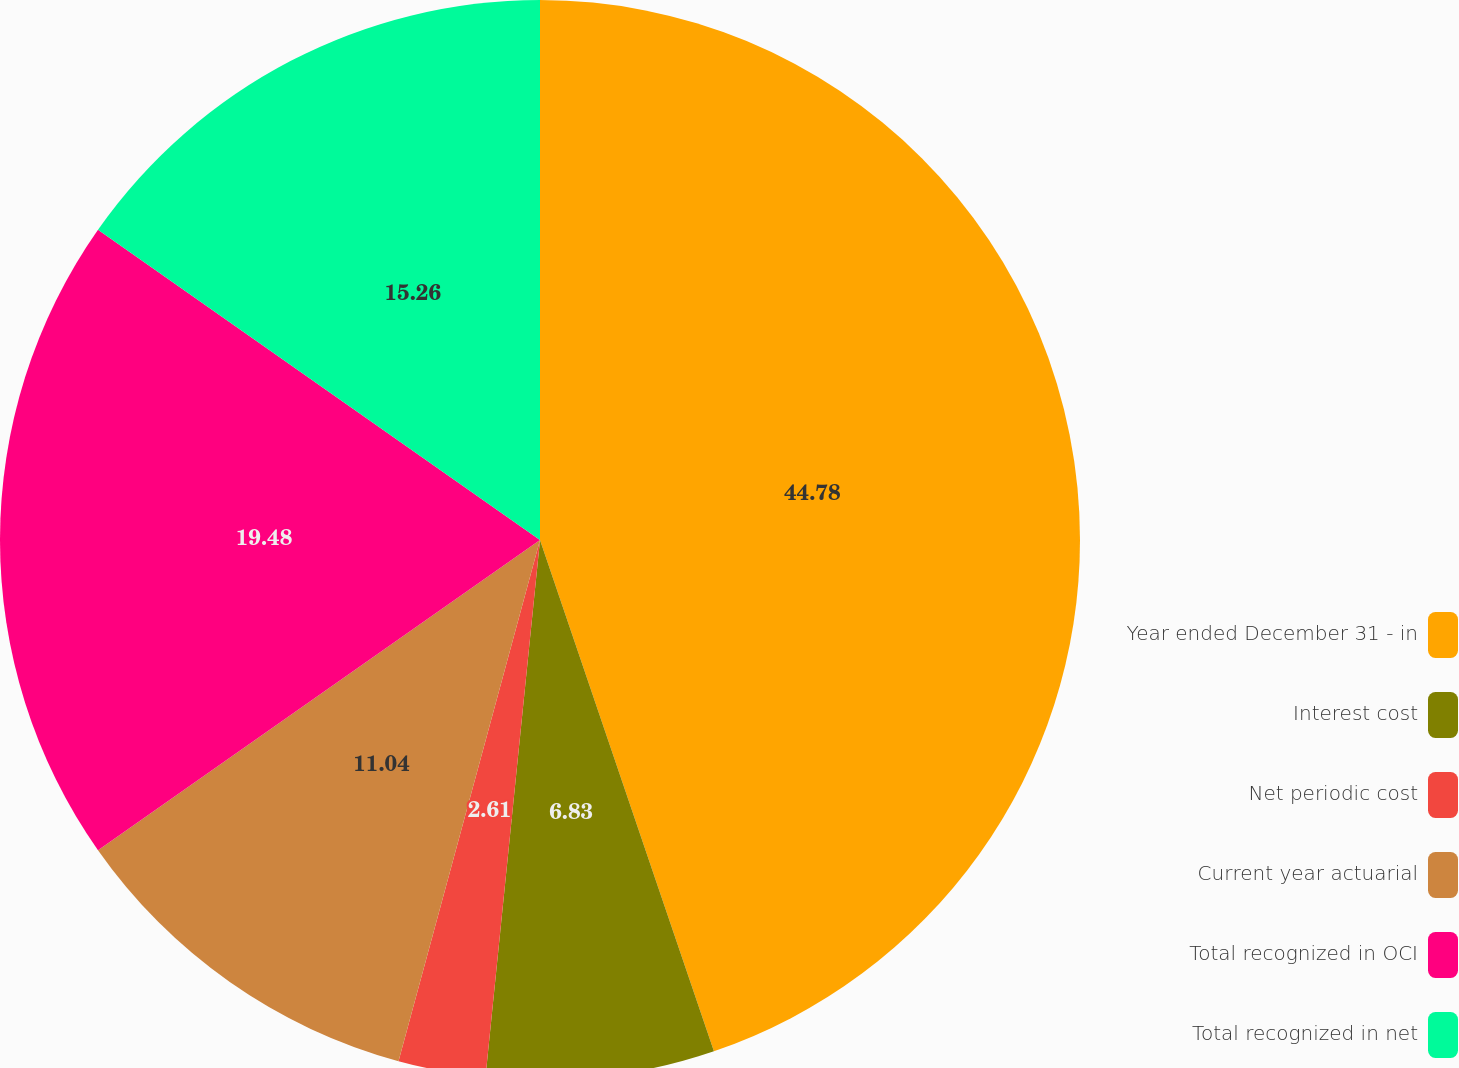Convert chart. <chart><loc_0><loc_0><loc_500><loc_500><pie_chart><fcel>Year ended December 31 - in<fcel>Interest cost<fcel>Net periodic cost<fcel>Current year actuarial<fcel>Total recognized in OCI<fcel>Total recognized in net<nl><fcel>44.78%<fcel>6.83%<fcel>2.61%<fcel>11.04%<fcel>19.48%<fcel>15.26%<nl></chart> 